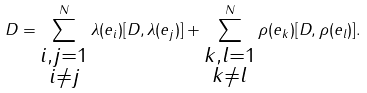Convert formula to latex. <formula><loc_0><loc_0><loc_500><loc_500>D = \sum _ { \substack { i , j = 1 \\ i \neq j } } ^ { N } \lambda ( e _ { i } ) [ D , \lambda ( e _ { j } ) ] + \sum _ { \substack { k , l = 1 \\ k \neq l } } ^ { N } \rho ( e _ { k } ) [ D , \rho ( e _ { l } ) ] .</formula> 